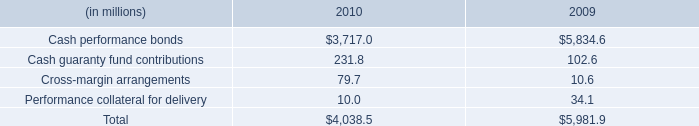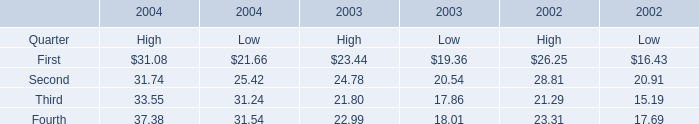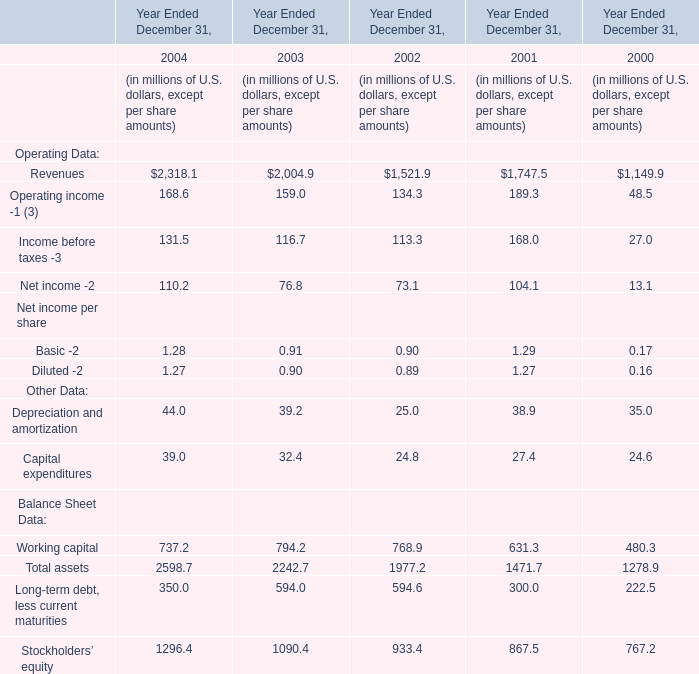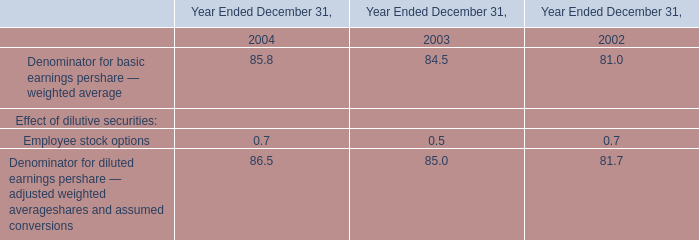In which year is Second for High greater than 30? 
Answer: 2004. 